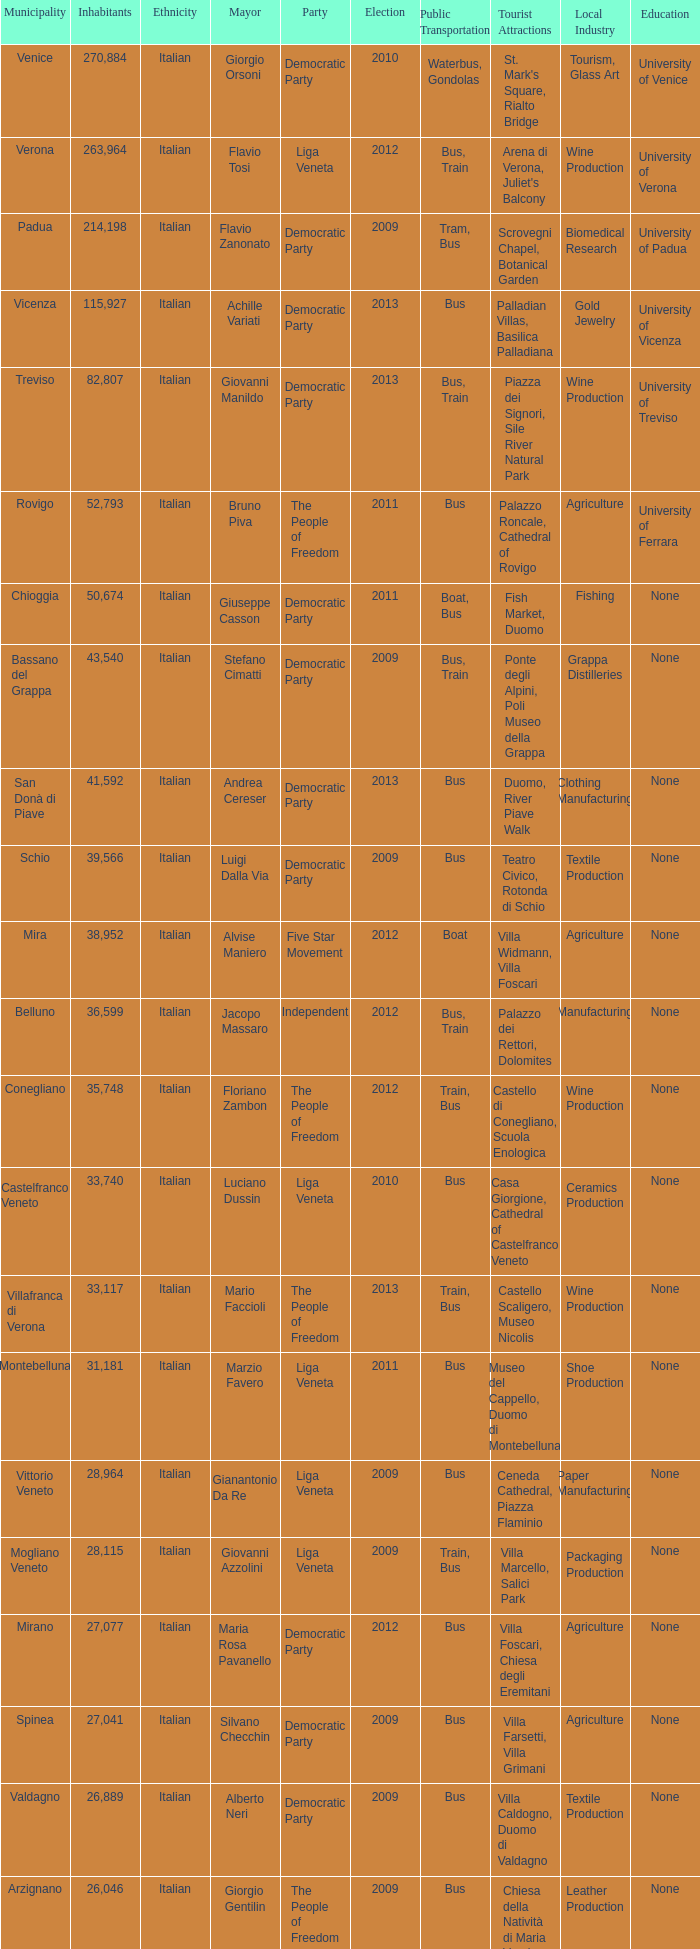In the election earlier than 2012 how many Inhabitants had a Party of five star movement? None. Could you parse the entire table as a dict? {'header': ['Municipality', 'Inhabitants', 'Ethnicity', 'Mayor', 'Party', 'Election', 'Public Transportation', 'Tourist Attractions', 'Local Industry', 'Education '], 'rows': [['Venice', '270,884', 'Italian', 'Giorgio Orsoni', 'Democratic Party', '2010', 'Waterbus, Gondolas', "St. Mark's Square, Rialto Bridge", 'Tourism, Glass Art', 'University of Venice'], ['Verona', '263,964', 'Italian', 'Flavio Tosi', 'Liga Veneta', '2012', 'Bus, Train', "Arena di Verona, Juliet's Balcony", 'Wine Production', 'University of Verona'], ['Padua', '214,198', 'Italian', 'Flavio Zanonato', 'Democratic Party', '2009', 'Tram, Bus', 'Scrovegni Chapel, Botanical Garden', 'Biomedical Research', 'University of Padua'], ['Vicenza', '115,927', 'Italian', 'Achille Variati', 'Democratic Party', '2013', 'Bus', 'Palladian Villas, Basilica Palladiana', 'Gold Jewelry', 'University of Vicenza'], ['Treviso', '82,807', 'Italian', 'Giovanni Manildo', 'Democratic Party', '2013', 'Bus, Train', 'Piazza dei Signori, Sile River Natural Park', 'Wine Production', 'University of Treviso'], ['Rovigo', '52,793', 'Italian', 'Bruno Piva', 'The People of Freedom', '2011', 'Bus', 'Palazzo Roncale, Cathedral of Rovigo', 'Agriculture', 'University of Ferrara '], ['Chioggia', '50,674', 'Italian', 'Giuseppe Casson', 'Democratic Party', '2011', 'Boat, Bus', 'Fish Market, Duomo', 'Fishing', 'None'], ['Bassano del Grappa', '43,540', 'Italian', 'Stefano Cimatti', 'Democratic Party', '2009', 'Bus, Train', 'Ponte degli Alpini, Poli Museo della Grappa', 'Grappa Distilleries', 'None'], ['San Donà di Piave', '41,592', 'Italian', 'Andrea Cereser', 'Democratic Party', '2013', 'Bus', 'Duomo, River Piave Walk', 'Clothing Manufacturing', 'None'], ['Schio', '39,566', 'Italian', 'Luigi Dalla Via', 'Democratic Party', '2009', 'Bus', 'Teatro Civico, Rotonda di Schio', 'Textile Production', 'None'], ['Mira', '38,952', 'Italian', 'Alvise Maniero', 'Five Star Movement', '2012', 'Boat', 'Villa Widmann, Villa Foscari', 'Agriculture', 'None'], ['Belluno', '36,599', 'Italian', 'Jacopo Massaro', 'Independent', '2012', 'Bus, Train', 'Palazzo dei Rettori, Dolomites', 'Manufacturing', 'None'], ['Conegliano', '35,748', 'Italian', 'Floriano Zambon', 'The People of Freedom', '2012', 'Train, Bus', 'Castello di Conegliano, Scuola Enologica', 'Wine Production', 'None'], ['Castelfranco Veneto', '33,740', 'Italian', 'Luciano Dussin', 'Liga Veneta', '2010', 'Bus', 'Casa Giorgione, Cathedral of Castelfranco Veneto', 'Ceramics Production', 'None'], ['Villafranca di Verona', '33,117', 'Italian', 'Mario Faccioli', 'The People of Freedom', '2013', 'Train, Bus', 'Castello Scaligero, Museo Nicolis', 'Wine Production', 'None'], ['Montebelluna', '31,181', 'Italian', 'Marzio Favero', 'Liga Veneta', '2011', 'Bus', 'Museo del Cappello, Duomo di Montebelluna', 'Shoe Production', 'None'], ['Vittorio Veneto', '28,964', 'Italian', 'Gianantonio Da Re', 'Liga Veneta', '2009', 'Bus', 'Ceneda Cathedral, Piazza Flaminio', 'Paper Manufacturing', 'None'], ['Mogliano Veneto', '28,115', 'Italian', 'Giovanni Azzolini', 'Liga Veneta', '2009', 'Train, Bus', 'Villa Marcello, Salici Park', 'Packaging Production', 'None'], ['Mirano', '27,077', 'Italian', 'Maria Rosa Pavanello', 'Democratic Party', '2012', 'Bus', 'Villa Foscari, Chiesa degli Eremitani', 'Agriculture', 'None'], ['Spinea', '27,041', 'Italian', 'Silvano Checchin', 'Democratic Party', '2009', 'Bus', 'Villa Farsetti, Villa Grimani', 'Agriculture', 'None'], ['Valdagno', '26,889', 'Italian', 'Alberto Neri', 'Democratic Party', '2009', 'Bus', 'Villa Caldogno, Duomo di Valdagno', 'Textile Production', 'None'], ['Arzignano', '26,046', 'Italian', 'Giorgio Gentilin', 'The People of Freedom', '2009', 'Bus', 'Chiesa della Natività di Maria Vergine, Pagoda Cinese', 'Leather Production', 'None'], ['Jesolo', '25,601', 'Italian', 'Valerio Zoggia', 'The People of Freedom', '2012', 'Bus', 'Sea Life Aquarium, Tropicarium Park', 'Tourism', 'None'], ['Legnago', '25,600', 'Italian', 'Roberto Rettondini', 'Liga Veneta', '2009', 'Bus', 'Santuario della Madonna della Salute, Castello di Bevilacqua', 'Agriculture', 'None'], ['Portogruaro', '25,440', 'Italian', 'Antonio Bertoncello', 'Democratic Party', '2010', 'Train, Bus', 'Castle of Portogruaro, Cathedral of Santa Maria Assunta', 'Agriculture', 'None']]} 